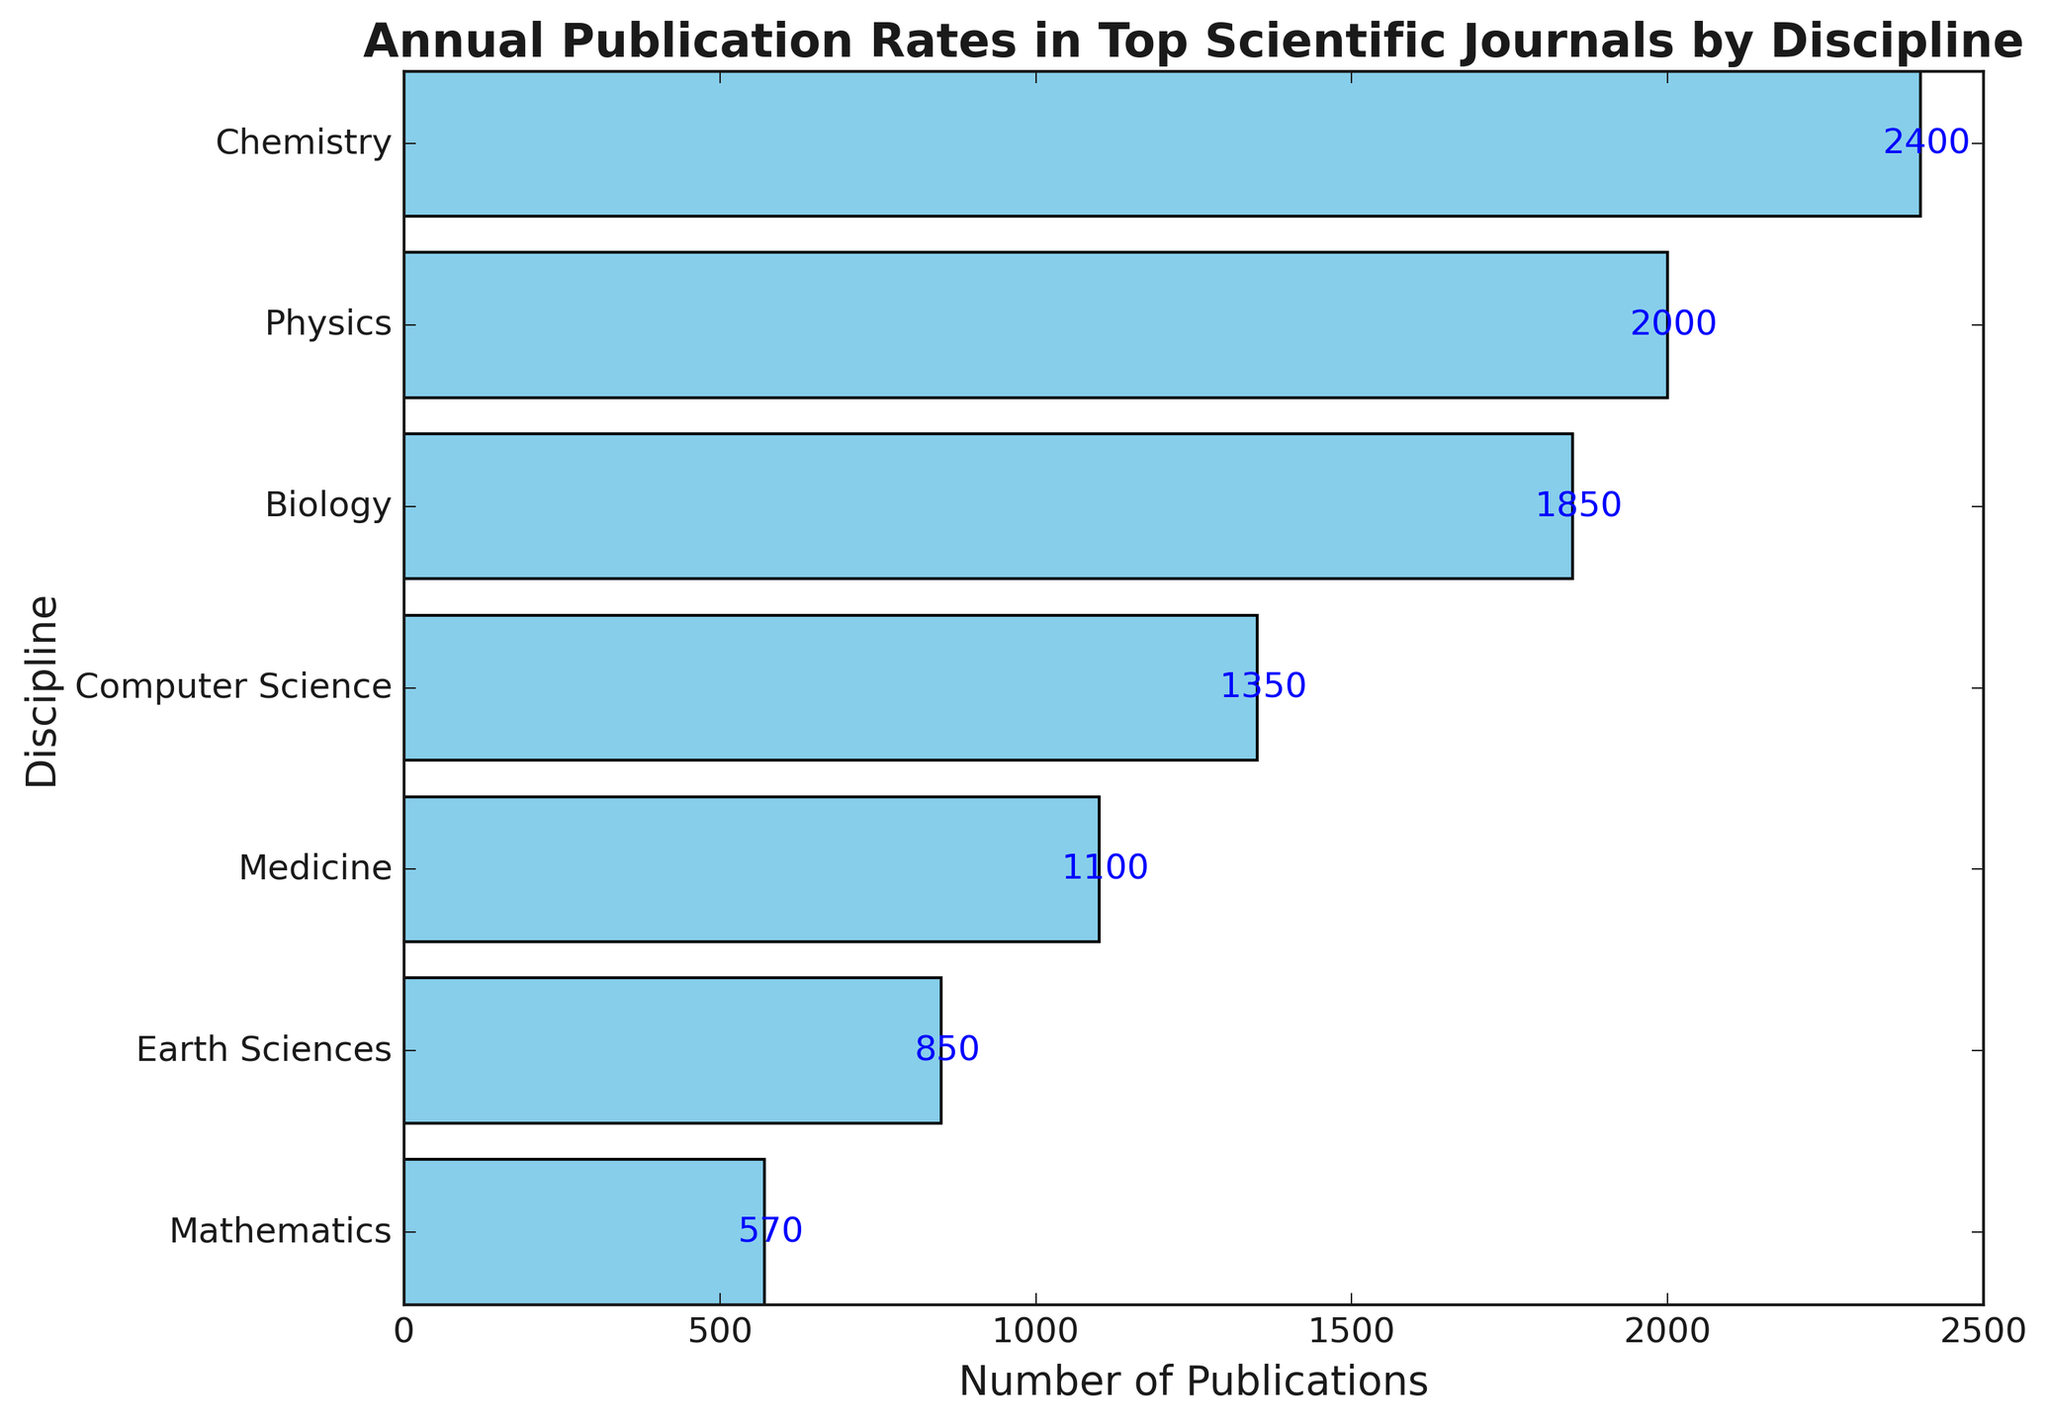Which discipline has the highest number of publications? By examining the horizontal bars, the longest bar corresponds to Chemistry. Summing up the number of publications for Chemistry, which includes 1300 for Journal of the American Chemical Society and 1100 for Angewandte Chemie International Edition, gives us the highest total.
Answer: Chemistry Which discipline has the lowest number of publications? By observing the horizontal bars, the shortest bar corresponds to Mathematics. Summing up the number of publications for Mathematics, which includes 300 for Journal of the American Mathematical Society and 270 for Mathematics of Computation, results in the lowest total.
Answer: Mathematics What are the total publications for Biology? The bars for Biology journals, Nature Communications and Journal of Biological Chemistry, indicate publication numbers. Summing these, 900 for Nature Communications and 950 for Journal of Biological Chemistry, gives us a total.
Answer: 1850 Compare the publication totals for Medicine and Earth Sciences. Which one has more and by how much? Looking at the bars, Medicine has publications of 500 and 600 (total 1100), and Earth Sciences has 400 and 450 (total 850). The difference is calculated by subtracting the total of Earth Sciences from Medicine's total.
Answer: Medicine by 250 What's the combined total of publications for Computer Science and Physics disciplines? Summing the values for Computer Science (700 for IEEE Transactions on Computers and 650 for ACM Transactions on Computer Systems) gives 1350, and for Physics (1200 for Physical Review Letters and 800 for Journal of Applied Physics) gives 2000. Adding these two totals results in the combined sum.
Answer: 3350 Which disciplines have publication totals between 1000 and 2000, inclusive? By reviewing the bars and sums, disciplines falling in the range 1000-2000 are Biology (1850), Physics (2000), and Computer Science (1350).
Answer: Biology, Computer Science, Physics What's the difference in publication numbers between the top journal in Chemistry and the top journal in Medicine? The top journal in Chemistry (Journal of the American Chemical Society) has 1300 publications and the top journal in Medicine (The Lancet) has 600 publications. Subtracting the Medicine number from the Chemistry number gives the difference.
Answer: 700 How many publications does the average journal in the Earth Sciences discipline have? The discipline's total publications are 850 (400 for Geophysical Research Letters and 450 for Journal of Geophysical Research). Dividing by the number of journals (2) gives the average.
Answer: 425 What is the difference in publications between the journal with the highest publication rate and the one with the lowest? The highest is Journal of the American Chemical Society with 1300 publications and the lowest is Mathematics of Computation with 270 publications. Subtracting the lowest from the highest gives the difference.
Answer: 1030 